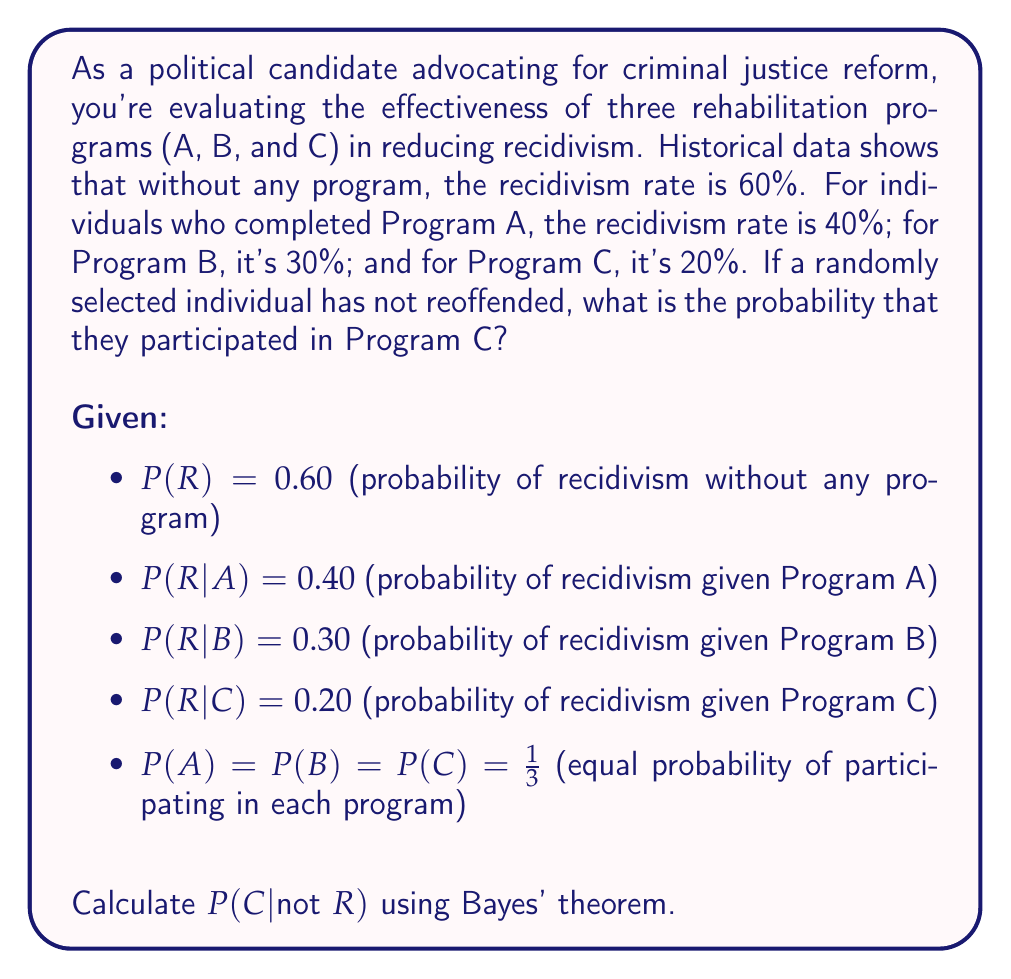Can you answer this question? To solve this problem, we'll use Bayes' theorem:

$$P(C|not R) = \frac{P(not R|C) \cdot P(C)}{P(not R)}$$

1. Calculate P(not R|C):
   P(not R|C) = 1 - P(R|C) = 1 - 0.20 = 0.80

2. We're given P(C) = 1/3

3. Calculate P(not R) using the law of total probability:
   $$P(not R) = P(not R|A)P(A) + P(not R|B)P(B) + P(not R|C)P(C)$$
   
   P(not R|A) = 1 - P(R|A) = 1 - 0.40 = 0.60
   P(not R|B) = 1 - P(R|B) = 1 - 0.30 = 0.70
   P(not R|C) = 1 - P(R|C) = 1 - 0.20 = 0.80

   $$P(not R) = 0.60 \cdot \frac{1}{3} + 0.70 \cdot \frac{1}{3} + 0.80 \cdot \frac{1}{3}$$
   $$P(not R) = \frac{0.60 + 0.70 + 0.80}{3} = \frac{2.10}{3} = 0.70$$

4. Apply Bayes' theorem:
   $$P(C|not R) = \frac{0.80 \cdot \frac{1}{3}}{0.70} = \frac{0.80}{2.10} \approx 0.3810$$

Therefore, the probability that a randomly selected individual who has not reoffended participated in Program C is approximately 0.3810 or 38.10%.
Answer: P(C|not R) ≈ 0.3810 or 38.10% 